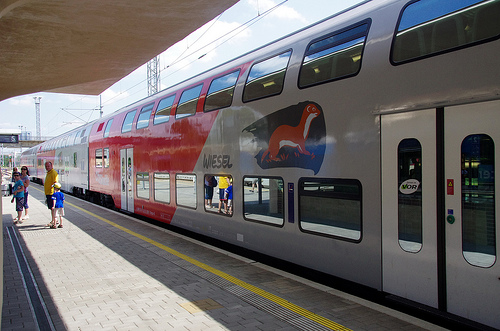Please provide the bounding box coordinate of the region this sentence describes: a man is wearing a yellow shirt. The coordinates [0.07, 0.48, 0.12, 0.55] identify the area of the image where a man is seen wearing a yellow shirt. A more centered and precise adjustment would enhance the clarity and focus on the subject. 